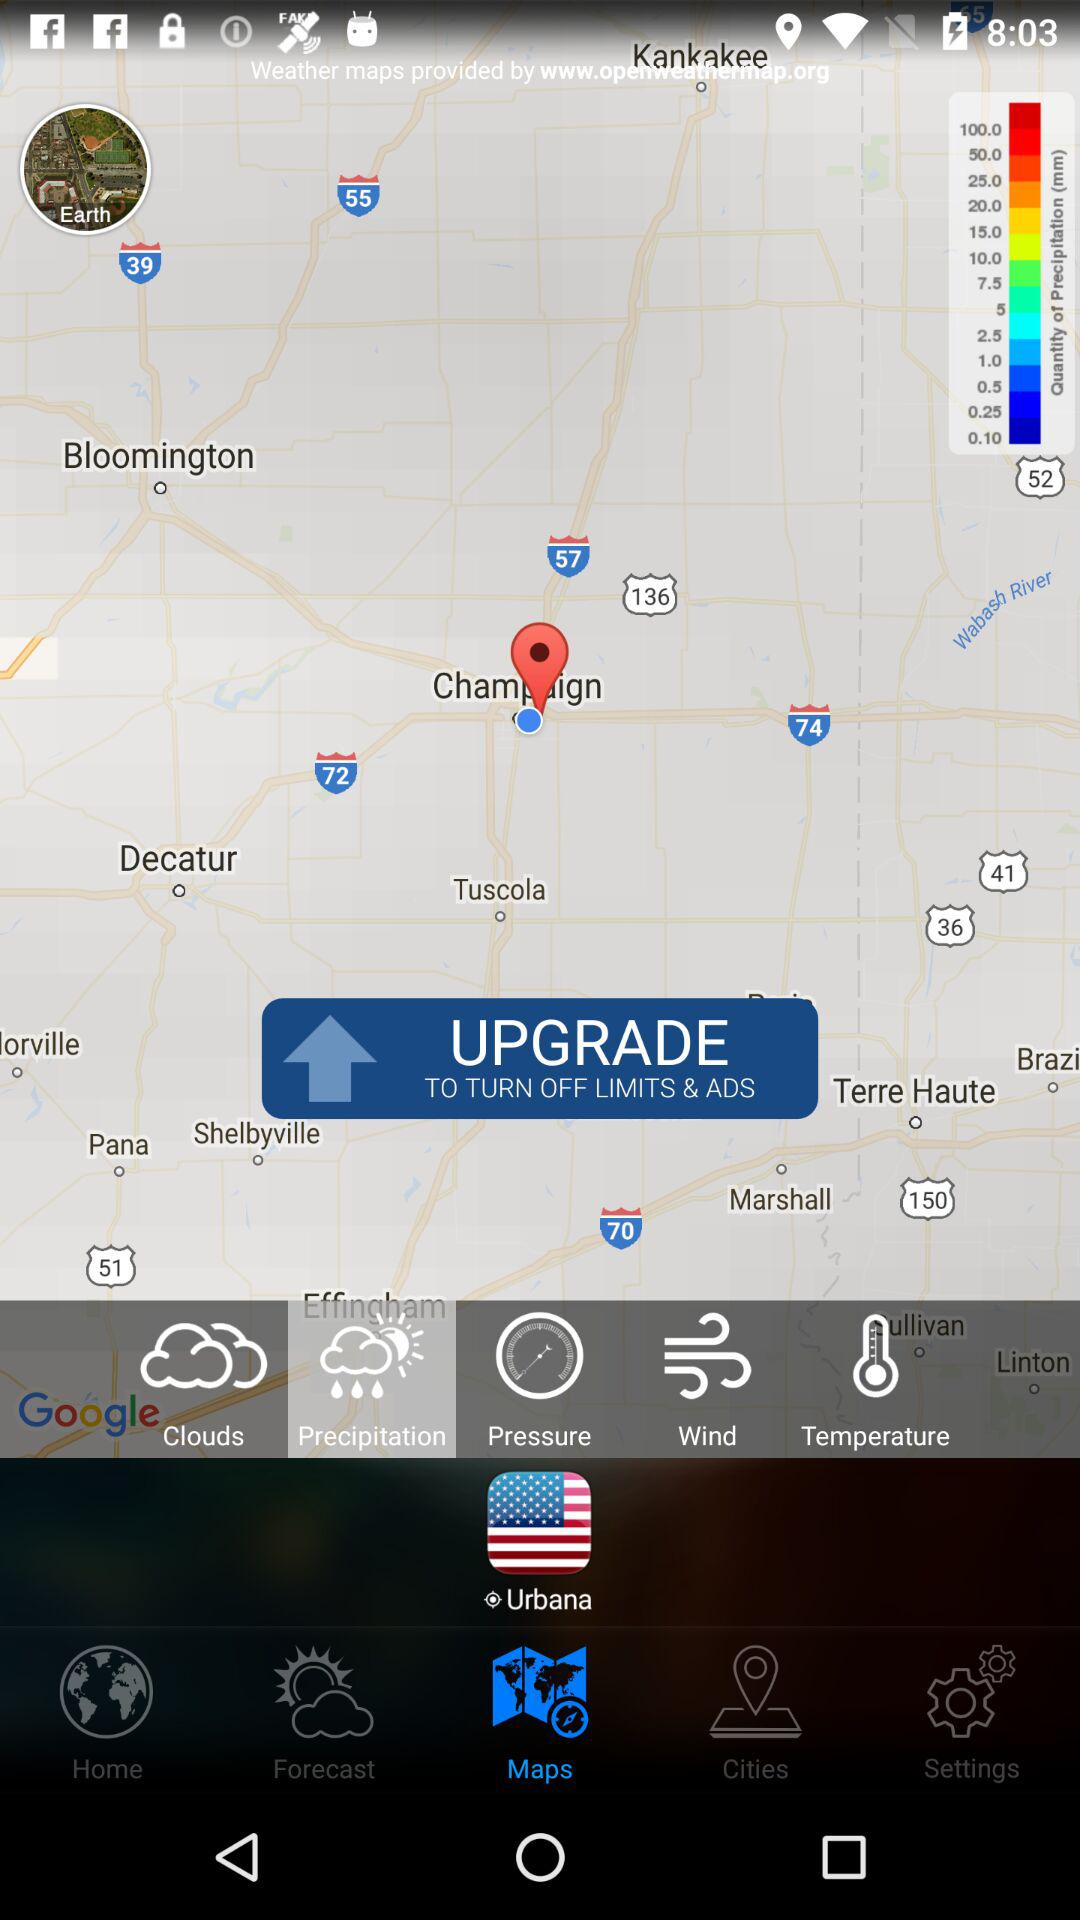What is the selected tab? The selected tab is "Maps". 